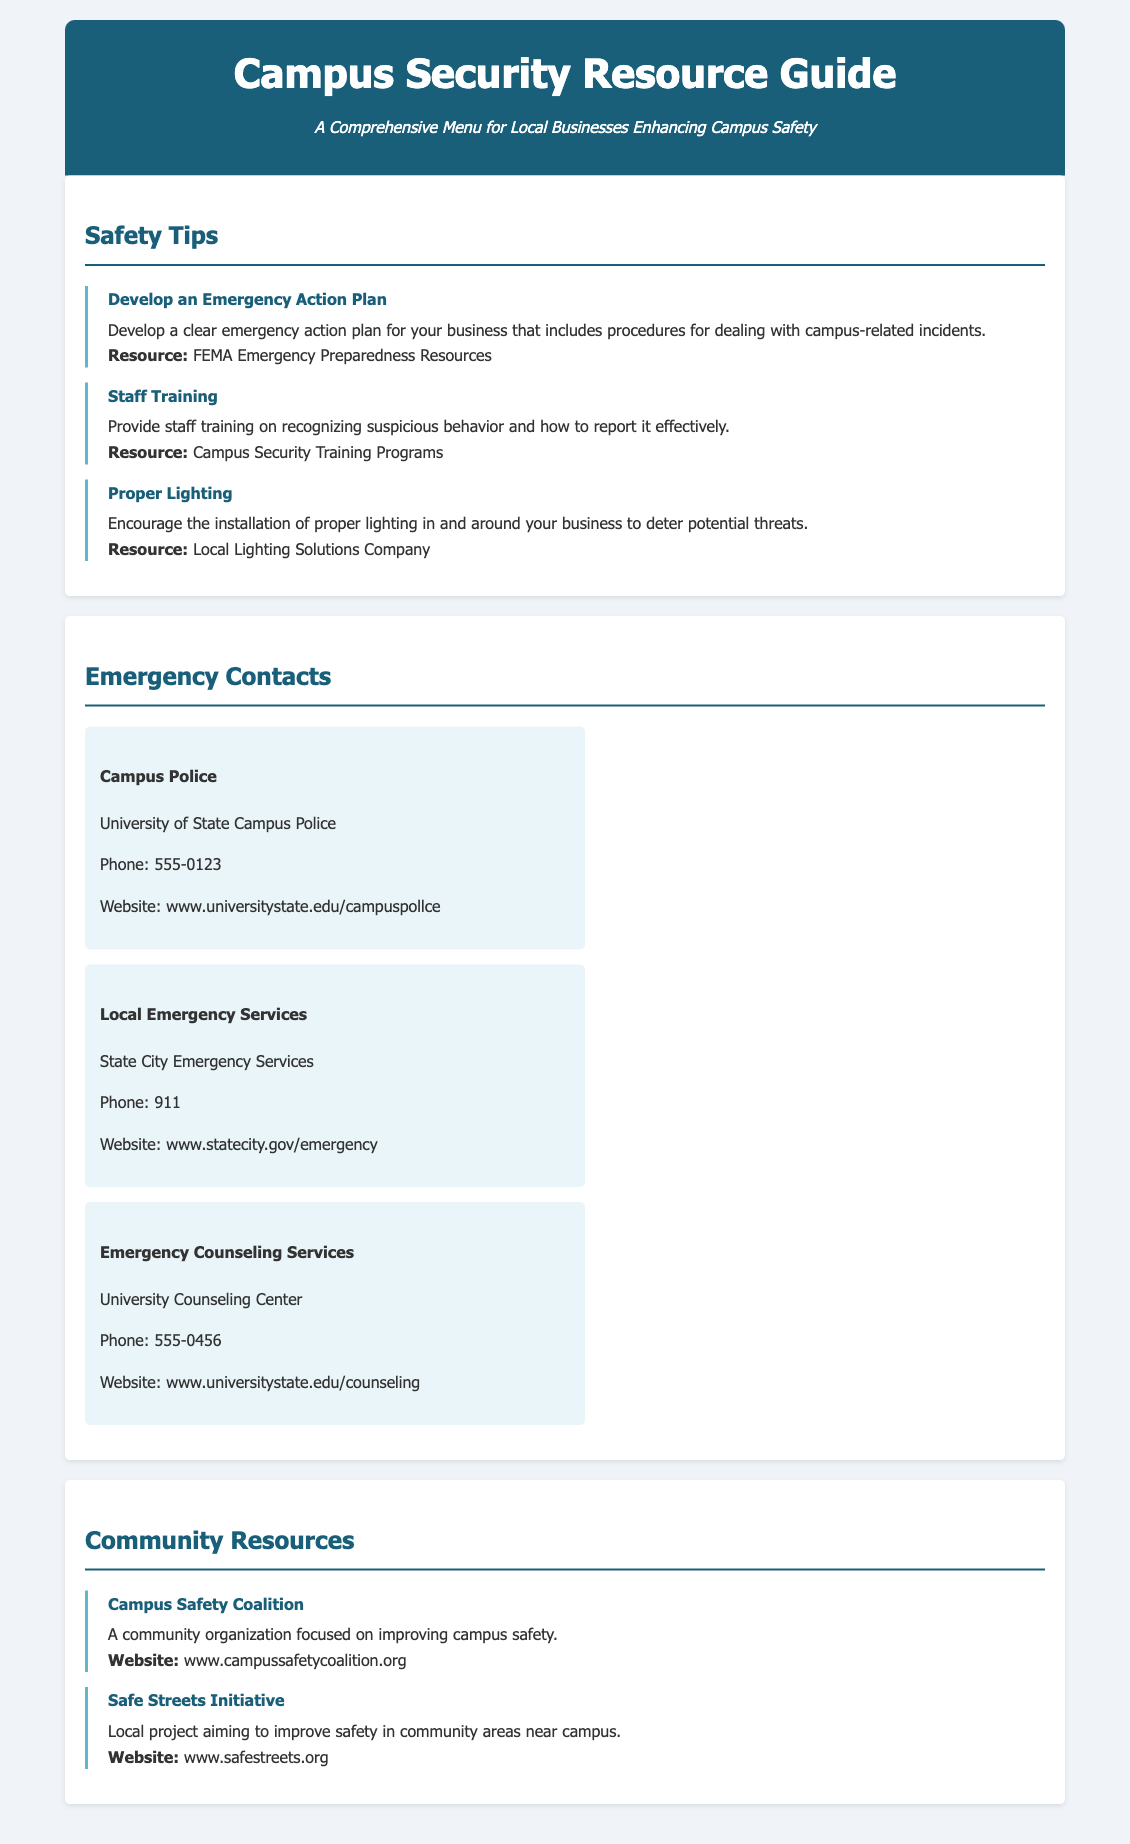What is the first resource listed in Safety Tips? The first resource listed in Safety Tips is "Develop an Emergency Action Plan."
Answer: Develop an Emergency Action Plan What is the phone number for Campus Police? The phone number for Campus Police is provided in the contact section of the document.
Answer: 555-0123 What organization focuses on improving campus safety? The organization mentioned in the community resources section is the "Campus Safety Coalition."
Answer: Campus Safety Coalition What is the website for Local Emergency Services? The website for Local Emergency Services is listed in the contact information section.
Answer: www.statecity.gov/emergency What is suggested to deter potential threats around businesses? The document suggests the installation of "proper lighting" to deter threats.
Answer: Proper lighting What emergency service’s phone number is listed as 911? The phone number 911 is listed under Local Emergency Services.
Answer: Local Emergency Services What is a recommended training focus for staff? The document recommends training staff on "recognizing suspicious behavior."
Answer: Recognizing suspicious behavior What initiative aims to improve safety in community areas near campus? The initiative mentioned to improve safety is the "Safe Streets Initiative."
Answer: Safe Streets Initiative 